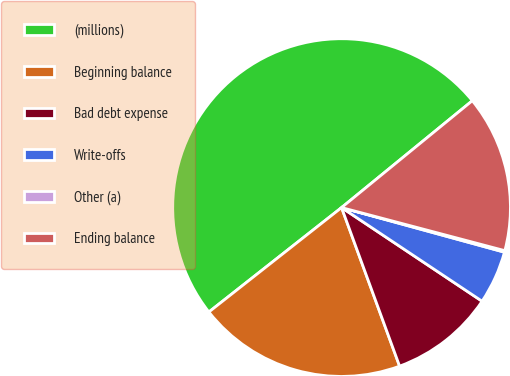Convert chart to OTSL. <chart><loc_0><loc_0><loc_500><loc_500><pie_chart><fcel>(millions)<fcel>Beginning balance<fcel>Bad debt expense<fcel>Write-offs<fcel>Other (a)<fcel>Ending balance<nl><fcel>49.7%<fcel>19.97%<fcel>10.06%<fcel>5.1%<fcel>0.15%<fcel>15.01%<nl></chart> 